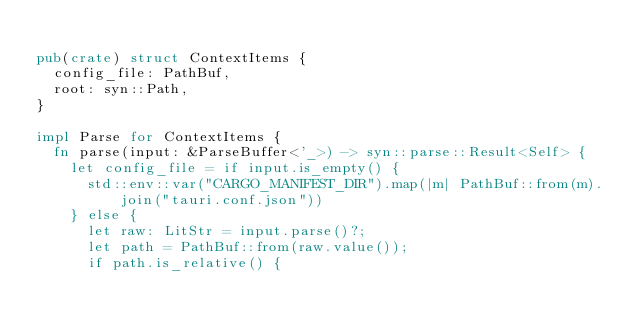<code> <loc_0><loc_0><loc_500><loc_500><_Rust_>
pub(crate) struct ContextItems {
  config_file: PathBuf,
  root: syn::Path,
}

impl Parse for ContextItems {
  fn parse(input: &ParseBuffer<'_>) -> syn::parse::Result<Self> {
    let config_file = if input.is_empty() {
      std::env::var("CARGO_MANIFEST_DIR").map(|m| PathBuf::from(m).join("tauri.conf.json"))
    } else {
      let raw: LitStr = input.parse()?;
      let path = PathBuf::from(raw.value());
      if path.is_relative() {</code> 